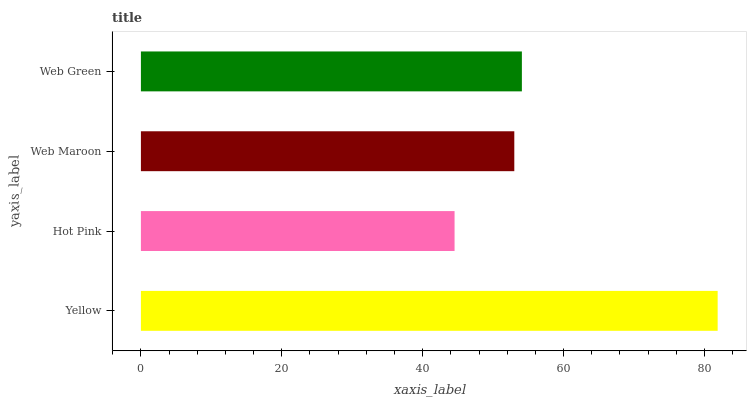Is Hot Pink the minimum?
Answer yes or no. Yes. Is Yellow the maximum?
Answer yes or no. Yes. Is Web Maroon the minimum?
Answer yes or no. No. Is Web Maroon the maximum?
Answer yes or no. No. Is Web Maroon greater than Hot Pink?
Answer yes or no. Yes. Is Hot Pink less than Web Maroon?
Answer yes or no. Yes. Is Hot Pink greater than Web Maroon?
Answer yes or no. No. Is Web Maroon less than Hot Pink?
Answer yes or no. No. Is Web Green the high median?
Answer yes or no. Yes. Is Web Maroon the low median?
Answer yes or no. Yes. Is Hot Pink the high median?
Answer yes or no. No. Is Web Green the low median?
Answer yes or no. No. 